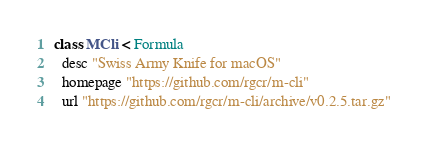Convert code to text. <code><loc_0><loc_0><loc_500><loc_500><_Ruby_>class MCli < Formula
  desc "Swiss Army Knife for macOS"
  homepage "https://github.com/rgcr/m-cli"
  url "https://github.com/rgcr/m-cli/archive/v0.2.5.tar.gz"</code> 